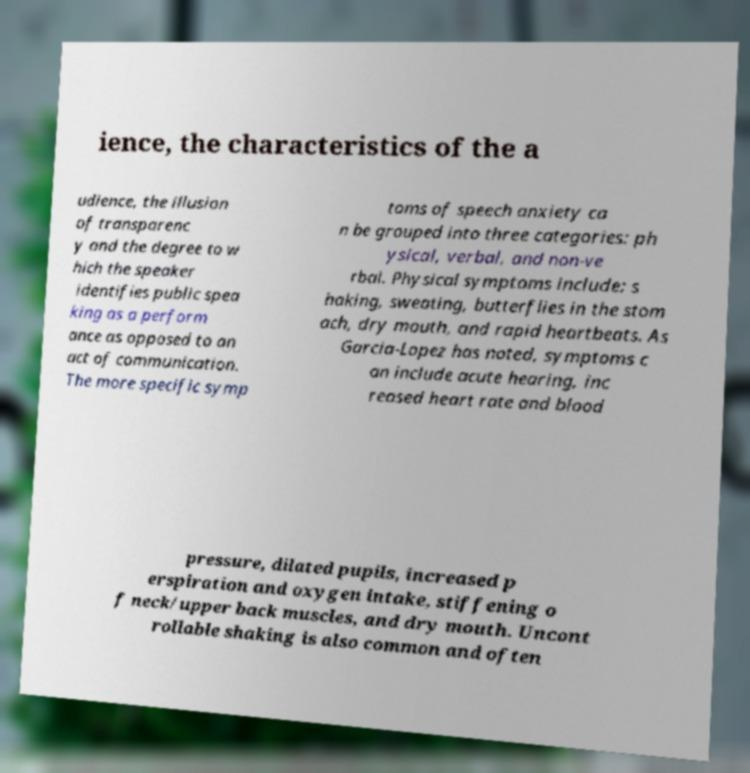Please identify and transcribe the text found in this image. ience, the characteristics of the a udience, the illusion of transparenc y and the degree to w hich the speaker identifies public spea king as a perform ance as opposed to an act of communication. The more specific symp toms of speech anxiety ca n be grouped into three categories: ph ysical, verbal, and non-ve rbal. Physical symptoms include: s haking, sweating, butterflies in the stom ach, dry mouth, and rapid heartbeats. As Garcia-Lopez has noted, symptoms c an include acute hearing, inc reased heart rate and blood pressure, dilated pupils, increased p erspiration and oxygen intake, stiffening o f neck/upper back muscles, and dry mouth. Uncont rollable shaking is also common and often 